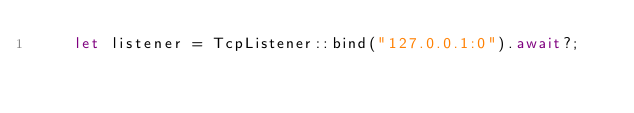<code> <loc_0><loc_0><loc_500><loc_500><_Rust_>    let listener = TcpListener::bind("127.0.0.1:0").await?;</code> 